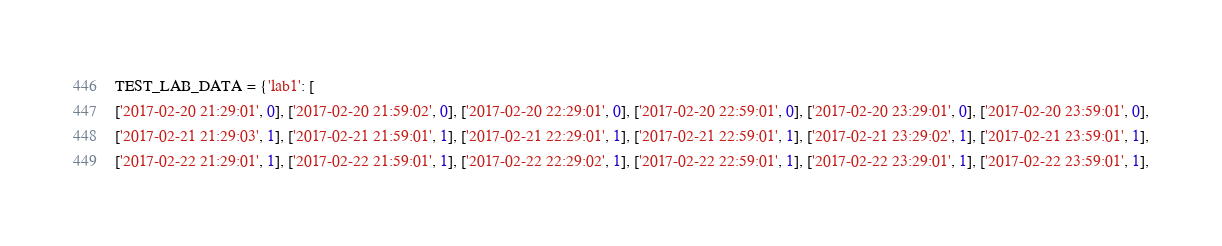<code> <loc_0><loc_0><loc_500><loc_500><_Python_>
TEST_LAB_DATA = {'lab1': [
['2017-02-20 21:29:01', 0], ['2017-02-20 21:59:02', 0], ['2017-02-20 22:29:01', 0], ['2017-02-20 22:59:01', 0], ['2017-02-20 23:29:01', 0], ['2017-02-20 23:59:01', 0],
['2017-02-21 21:29:03', 1], ['2017-02-21 21:59:01', 1], ['2017-02-21 22:29:01', 1], ['2017-02-21 22:59:01', 1], ['2017-02-21 23:29:02', 1], ['2017-02-21 23:59:01', 1],
['2017-02-22 21:29:01', 1], ['2017-02-22 21:59:01', 1], ['2017-02-22 22:29:02', 1], ['2017-02-22 22:59:01', 1], ['2017-02-22 23:29:01', 1], ['2017-02-22 23:59:01', 1],</code> 